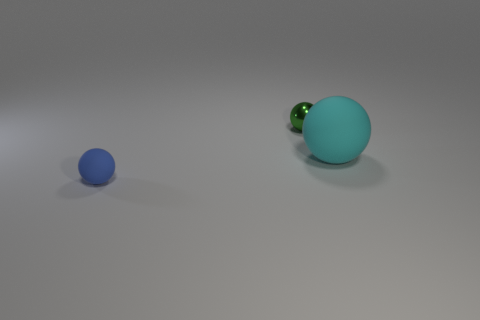Is the material of the tiny object that is behind the cyan matte object the same as the tiny blue object that is to the left of the cyan thing?
Offer a very short reply. No. What number of spheres are big objects or small things?
Your response must be concise. 3. There is a big ball behind the matte object to the left of the small green shiny ball; what number of big rubber balls are to the right of it?
Offer a terse response. 0. There is a small green object that is the same shape as the cyan matte thing; what material is it?
Make the answer very short. Metal. Are there any other things that are made of the same material as the green ball?
Your answer should be very brief. No. There is a thing that is to the right of the shiny ball; what is its color?
Your answer should be very brief. Cyan. Is the material of the tiny blue object the same as the small object that is behind the big rubber sphere?
Offer a terse response. No. What material is the small green thing?
Your response must be concise. Metal. The other blue thing that is made of the same material as the large thing is what shape?
Ensure brevity in your answer.  Sphere. What number of other objects are the same shape as the cyan object?
Provide a short and direct response. 2. 